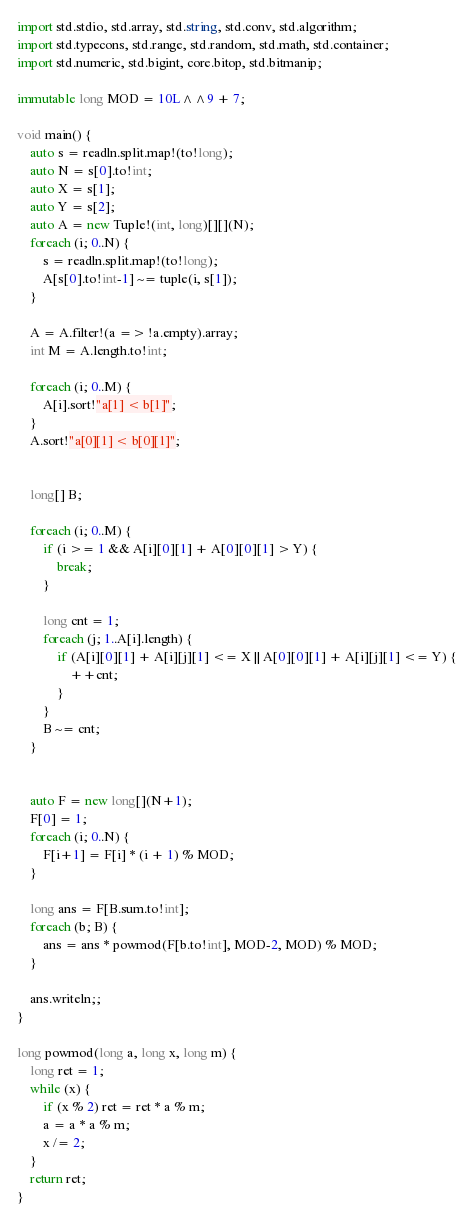Convert code to text. <code><loc_0><loc_0><loc_500><loc_500><_D_>import std.stdio, std.array, std.string, std.conv, std.algorithm;
import std.typecons, std.range, std.random, std.math, std.container;
import std.numeric, std.bigint, core.bitop, std.bitmanip;

immutable long MOD = 10L^^9 + 7;

void main() {
    auto s = readln.split.map!(to!long);
    auto N = s[0].to!int;
    auto X = s[1];
    auto Y = s[2];
    auto A = new Tuple!(int, long)[][](N);
    foreach (i; 0..N) {
        s = readln.split.map!(to!long);
        A[s[0].to!int-1] ~= tuple(i, s[1]);
    }

    A = A.filter!(a => !a.empty).array;
    int M = A.length.to!int;
    
    foreach (i; 0..M) {
        A[i].sort!"a[1] < b[1]";
    }
    A.sort!"a[0][1] < b[0][1]";

    
    long[] B;
    
    foreach (i; 0..M) {
        if (i >= 1 && A[i][0][1] + A[0][0][1] > Y) {
            break;
        }
        
        long cnt = 1;
        foreach (j; 1..A[i].length) {
            if (A[i][0][1] + A[i][j][1] <= X || A[0][0][1] + A[i][j][1] <= Y) {
                ++cnt;
            }
        }
        B ~= cnt;
    }


    auto F = new long[](N+1);
    F[0] = 1;
    foreach (i; 0..N) {
        F[i+1] = F[i] * (i + 1) % MOD;
    }

    long ans = F[B.sum.to!int];
    foreach (b; B) {
        ans = ans * powmod(F[b.to!int], MOD-2, MOD) % MOD;
    }
    
    ans.writeln;;
}

long powmod(long a, long x, long m) {
    long ret = 1;
    while (x) {
        if (x % 2) ret = ret * a % m;
        a = a * a % m;
        x /= 2;
    }
    return ret;
}
</code> 